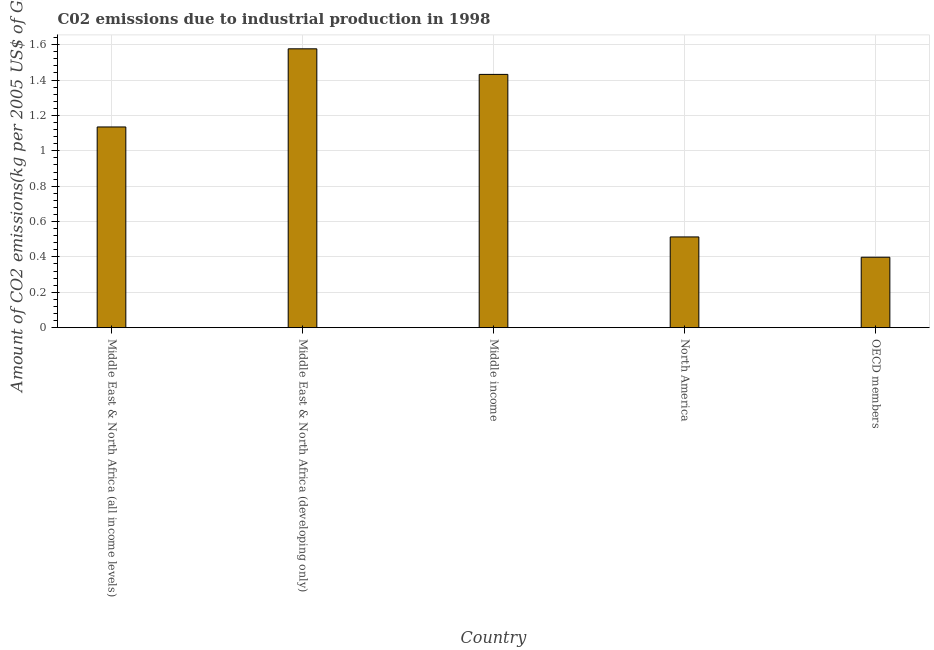What is the title of the graph?
Ensure brevity in your answer.  C02 emissions due to industrial production in 1998. What is the label or title of the X-axis?
Provide a succinct answer. Country. What is the label or title of the Y-axis?
Offer a very short reply. Amount of CO2 emissions(kg per 2005 US$ of GDP). What is the amount of co2 emissions in OECD members?
Give a very brief answer. 0.4. Across all countries, what is the maximum amount of co2 emissions?
Your response must be concise. 1.58. Across all countries, what is the minimum amount of co2 emissions?
Give a very brief answer. 0.4. In which country was the amount of co2 emissions maximum?
Your response must be concise. Middle East & North Africa (developing only). In which country was the amount of co2 emissions minimum?
Give a very brief answer. OECD members. What is the sum of the amount of co2 emissions?
Your answer should be compact. 5.05. What is the difference between the amount of co2 emissions in Middle East & North Africa (all income levels) and OECD members?
Give a very brief answer. 0.74. What is the average amount of co2 emissions per country?
Offer a terse response. 1.01. What is the median amount of co2 emissions?
Offer a very short reply. 1.13. What is the ratio of the amount of co2 emissions in North America to that in OECD members?
Your response must be concise. 1.29. Is the amount of co2 emissions in Middle East & North Africa (developing only) less than that in North America?
Your response must be concise. No. Is the difference between the amount of co2 emissions in Middle East & North Africa (developing only) and North America greater than the difference between any two countries?
Provide a short and direct response. No. What is the difference between the highest and the second highest amount of co2 emissions?
Give a very brief answer. 0.14. What is the difference between the highest and the lowest amount of co2 emissions?
Offer a terse response. 1.18. In how many countries, is the amount of co2 emissions greater than the average amount of co2 emissions taken over all countries?
Make the answer very short. 3. How many bars are there?
Offer a terse response. 5. Are all the bars in the graph horizontal?
Your response must be concise. No. What is the difference between two consecutive major ticks on the Y-axis?
Ensure brevity in your answer.  0.2. What is the Amount of CO2 emissions(kg per 2005 US$ of GDP) of Middle East & North Africa (all income levels)?
Provide a succinct answer. 1.13. What is the Amount of CO2 emissions(kg per 2005 US$ of GDP) of Middle East & North Africa (developing only)?
Your response must be concise. 1.58. What is the Amount of CO2 emissions(kg per 2005 US$ of GDP) of Middle income?
Provide a short and direct response. 1.43. What is the Amount of CO2 emissions(kg per 2005 US$ of GDP) of North America?
Your response must be concise. 0.51. What is the Amount of CO2 emissions(kg per 2005 US$ of GDP) of OECD members?
Offer a terse response. 0.4. What is the difference between the Amount of CO2 emissions(kg per 2005 US$ of GDP) in Middle East & North Africa (all income levels) and Middle East & North Africa (developing only)?
Keep it short and to the point. -0.44. What is the difference between the Amount of CO2 emissions(kg per 2005 US$ of GDP) in Middle East & North Africa (all income levels) and Middle income?
Keep it short and to the point. -0.3. What is the difference between the Amount of CO2 emissions(kg per 2005 US$ of GDP) in Middle East & North Africa (all income levels) and North America?
Keep it short and to the point. 0.62. What is the difference between the Amount of CO2 emissions(kg per 2005 US$ of GDP) in Middle East & North Africa (all income levels) and OECD members?
Offer a very short reply. 0.74. What is the difference between the Amount of CO2 emissions(kg per 2005 US$ of GDP) in Middle East & North Africa (developing only) and Middle income?
Keep it short and to the point. 0.14. What is the difference between the Amount of CO2 emissions(kg per 2005 US$ of GDP) in Middle East & North Africa (developing only) and North America?
Ensure brevity in your answer.  1.06. What is the difference between the Amount of CO2 emissions(kg per 2005 US$ of GDP) in Middle East & North Africa (developing only) and OECD members?
Give a very brief answer. 1.18. What is the difference between the Amount of CO2 emissions(kg per 2005 US$ of GDP) in Middle income and North America?
Your response must be concise. 0.92. What is the difference between the Amount of CO2 emissions(kg per 2005 US$ of GDP) in Middle income and OECD members?
Give a very brief answer. 1.03. What is the difference between the Amount of CO2 emissions(kg per 2005 US$ of GDP) in North America and OECD members?
Your answer should be very brief. 0.11. What is the ratio of the Amount of CO2 emissions(kg per 2005 US$ of GDP) in Middle East & North Africa (all income levels) to that in Middle East & North Africa (developing only)?
Your response must be concise. 0.72. What is the ratio of the Amount of CO2 emissions(kg per 2005 US$ of GDP) in Middle East & North Africa (all income levels) to that in Middle income?
Offer a very short reply. 0.79. What is the ratio of the Amount of CO2 emissions(kg per 2005 US$ of GDP) in Middle East & North Africa (all income levels) to that in North America?
Provide a short and direct response. 2.21. What is the ratio of the Amount of CO2 emissions(kg per 2005 US$ of GDP) in Middle East & North Africa (all income levels) to that in OECD members?
Make the answer very short. 2.85. What is the ratio of the Amount of CO2 emissions(kg per 2005 US$ of GDP) in Middle East & North Africa (developing only) to that in Middle income?
Provide a short and direct response. 1.1. What is the ratio of the Amount of CO2 emissions(kg per 2005 US$ of GDP) in Middle East & North Africa (developing only) to that in North America?
Your response must be concise. 3.07. What is the ratio of the Amount of CO2 emissions(kg per 2005 US$ of GDP) in Middle East & North Africa (developing only) to that in OECD members?
Make the answer very short. 3.96. What is the ratio of the Amount of CO2 emissions(kg per 2005 US$ of GDP) in Middle income to that in North America?
Your response must be concise. 2.79. What is the ratio of the Amount of CO2 emissions(kg per 2005 US$ of GDP) in Middle income to that in OECD members?
Your response must be concise. 3.6. What is the ratio of the Amount of CO2 emissions(kg per 2005 US$ of GDP) in North America to that in OECD members?
Keep it short and to the point. 1.29. 